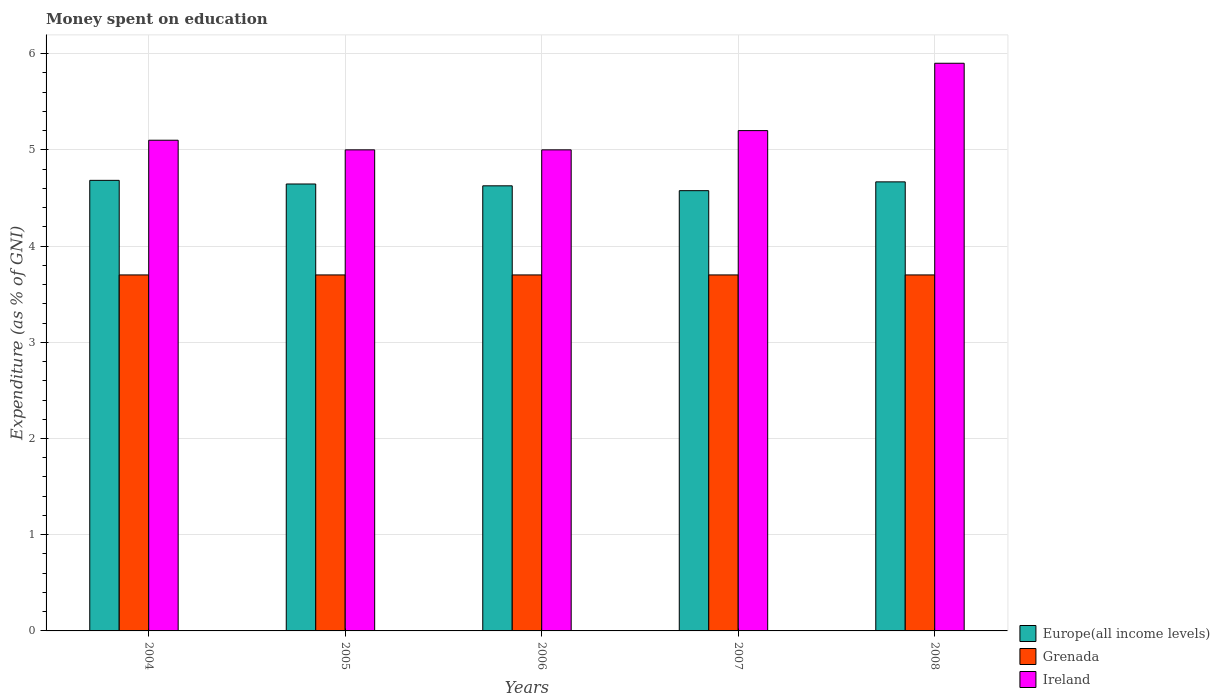How many different coloured bars are there?
Provide a short and direct response. 3. Are the number of bars on each tick of the X-axis equal?
Provide a succinct answer. Yes. What is the label of the 1st group of bars from the left?
Give a very brief answer. 2004. In how many cases, is the number of bars for a given year not equal to the number of legend labels?
Make the answer very short. 0. What is the amount of money spent on education in Ireland in 2007?
Provide a short and direct response. 5.2. Across all years, what is the maximum amount of money spent on education in Grenada?
Ensure brevity in your answer.  3.7. Across all years, what is the minimum amount of money spent on education in Grenada?
Provide a succinct answer. 3.7. In which year was the amount of money spent on education in Ireland maximum?
Offer a very short reply. 2008. What is the total amount of money spent on education in Ireland in the graph?
Give a very brief answer. 26.2. What is the difference between the amount of money spent on education in Grenada in 2005 and that in 2006?
Offer a terse response. 0. What is the difference between the amount of money spent on education in Europe(all income levels) in 2007 and the amount of money spent on education in Grenada in 2005?
Give a very brief answer. 0.88. What is the average amount of money spent on education in Europe(all income levels) per year?
Make the answer very short. 4.64. In the year 2007, what is the difference between the amount of money spent on education in Ireland and amount of money spent on education in Grenada?
Your response must be concise. 1.5. In how many years, is the amount of money spent on education in Europe(all income levels) greater than 5.2 %?
Offer a terse response. 0. What is the ratio of the amount of money spent on education in Europe(all income levels) in 2004 to that in 2005?
Ensure brevity in your answer.  1.01. What is the difference between the highest and the lowest amount of money spent on education in Ireland?
Offer a terse response. 0.9. What does the 1st bar from the left in 2004 represents?
Keep it short and to the point. Europe(all income levels). What does the 3rd bar from the right in 2008 represents?
Provide a short and direct response. Europe(all income levels). Is it the case that in every year, the sum of the amount of money spent on education in Ireland and amount of money spent on education in Europe(all income levels) is greater than the amount of money spent on education in Grenada?
Give a very brief answer. Yes. How many years are there in the graph?
Make the answer very short. 5. What is the difference between two consecutive major ticks on the Y-axis?
Provide a succinct answer. 1. Are the values on the major ticks of Y-axis written in scientific E-notation?
Ensure brevity in your answer.  No. Does the graph contain any zero values?
Your answer should be very brief. No. Where does the legend appear in the graph?
Provide a short and direct response. Bottom right. How many legend labels are there?
Keep it short and to the point. 3. How are the legend labels stacked?
Your response must be concise. Vertical. What is the title of the graph?
Keep it short and to the point. Money spent on education. Does "United Arab Emirates" appear as one of the legend labels in the graph?
Provide a short and direct response. No. What is the label or title of the Y-axis?
Your response must be concise. Expenditure (as % of GNI). What is the Expenditure (as % of GNI) in Europe(all income levels) in 2004?
Provide a succinct answer. 4.68. What is the Expenditure (as % of GNI) in Europe(all income levels) in 2005?
Give a very brief answer. 4.65. What is the Expenditure (as % of GNI) of Grenada in 2005?
Give a very brief answer. 3.7. What is the Expenditure (as % of GNI) of Ireland in 2005?
Make the answer very short. 5. What is the Expenditure (as % of GNI) in Europe(all income levels) in 2006?
Provide a short and direct response. 4.63. What is the Expenditure (as % of GNI) of Ireland in 2006?
Provide a succinct answer. 5. What is the Expenditure (as % of GNI) of Europe(all income levels) in 2007?
Your answer should be compact. 4.58. What is the Expenditure (as % of GNI) in Grenada in 2007?
Your answer should be very brief. 3.7. What is the Expenditure (as % of GNI) of Ireland in 2007?
Provide a succinct answer. 5.2. What is the Expenditure (as % of GNI) in Europe(all income levels) in 2008?
Offer a terse response. 4.67. Across all years, what is the maximum Expenditure (as % of GNI) of Europe(all income levels)?
Provide a short and direct response. 4.68. Across all years, what is the maximum Expenditure (as % of GNI) of Grenada?
Make the answer very short. 3.7. Across all years, what is the minimum Expenditure (as % of GNI) of Europe(all income levels)?
Keep it short and to the point. 4.58. Across all years, what is the minimum Expenditure (as % of GNI) in Ireland?
Your answer should be very brief. 5. What is the total Expenditure (as % of GNI) of Europe(all income levels) in the graph?
Offer a very short reply. 23.2. What is the total Expenditure (as % of GNI) of Ireland in the graph?
Your response must be concise. 26.2. What is the difference between the Expenditure (as % of GNI) of Europe(all income levels) in 2004 and that in 2005?
Give a very brief answer. 0.04. What is the difference between the Expenditure (as % of GNI) in Grenada in 2004 and that in 2005?
Offer a terse response. 0. What is the difference between the Expenditure (as % of GNI) of Europe(all income levels) in 2004 and that in 2006?
Give a very brief answer. 0.06. What is the difference between the Expenditure (as % of GNI) of Europe(all income levels) in 2004 and that in 2007?
Offer a terse response. 0.11. What is the difference between the Expenditure (as % of GNI) of Europe(all income levels) in 2004 and that in 2008?
Make the answer very short. 0.02. What is the difference between the Expenditure (as % of GNI) in Ireland in 2004 and that in 2008?
Ensure brevity in your answer.  -0.8. What is the difference between the Expenditure (as % of GNI) in Europe(all income levels) in 2005 and that in 2006?
Provide a short and direct response. 0.02. What is the difference between the Expenditure (as % of GNI) of Ireland in 2005 and that in 2006?
Provide a short and direct response. 0. What is the difference between the Expenditure (as % of GNI) of Europe(all income levels) in 2005 and that in 2007?
Your answer should be very brief. 0.07. What is the difference between the Expenditure (as % of GNI) in Grenada in 2005 and that in 2007?
Your answer should be compact. 0. What is the difference between the Expenditure (as % of GNI) in Europe(all income levels) in 2005 and that in 2008?
Your answer should be very brief. -0.02. What is the difference between the Expenditure (as % of GNI) in Ireland in 2005 and that in 2008?
Offer a very short reply. -0.9. What is the difference between the Expenditure (as % of GNI) in Europe(all income levels) in 2006 and that in 2007?
Ensure brevity in your answer.  0.05. What is the difference between the Expenditure (as % of GNI) of Europe(all income levels) in 2006 and that in 2008?
Offer a terse response. -0.04. What is the difference between the Expenditure (as % of GNI) of Europe(all income levels) in 2007 and that in 2008?
Ensure brevity in your answer.  -0.09. What is the difference between the Expenditure (as % of GNI) in Ireland in 2007 and that in 2008?
Keep it short and to the point. -0.7. What is the difference between the Expenditure (as % of GNI) in Europe(all income levels) in 2004 and the Expenditure (as % of GNI) in Grenada in 2005?
Your answer should be very brief. 0.98. What is the difference between the Expenditure (as % of GNI) of Europe(all income levels) in 2004 and the Expenditure (as % of GNI) of Ireland in 2005?
Your answer should be compact. -0.32. What is the difference between the Expenditure (as % of GNI) of Grenada in 2004 and the Expenditure (as % of GNI) of Ireland in 2005?
Give a very brief answer. -1.3. What is the difference between the Expenditure (as % of GNI) of Europe(all income levels) in 2004 and the Expenditure (as % of GNI) of Grenada in 2006?
Offer a very short reply. 0.98. What is the difference between the Expenditure (as % of GNI) in Europe(all income levels) in 2004 and the Expenditure (as % of GNI) in Ireland in 2006?
Ensure brevity in your answer.  -0.32. What is the difference between the Expenditure (as % of GNI) of Europe(all income levels) in 2004 and the Expenditure (as % of GNI) of Ireland in 2007?
Ensure brevity in your answer.  -0.52. What is the difference between the Expenditure (as % of GNI) in Grenada in 2004 and the Expenditure (as % of GNI) in Ireland in 2007?
Offer a terse response. -1.5. What is the difference between the Expenditure (as % of GNI) of Europe(all income levels) in 2004 and the Expenditure (as % of GNI) of Grenada in 2008?
Your response must be concise. 0.98. What is the difference between the Expenditure (as % of GNI) in Europe(all income levels) in 2004 and the Expenditure (as % of GNI) in Ireland in 2008?
Offer a terse response. -1.22. What is the difference between the Expenditure (as % of GNI) of Grenada in 2004 and the Expenditure (as % of GNI) of Ireland in 2008?
Provide a succinct answer. -2.2. What is the difference between the Expenditure (as % of GNI) in Europe(all income levels) in 2005 and the Expenditure (as % of GNI) in Grenada in 2006?
Keep it short and to the point. 0.95. What is the difference between the Expenditure (as % of GNI) in Europe(all income levels) in 2005 and the Expenditure (as % of GNI) in Ireland in 2006?
Keep it short and to the point. -0.35. What is the difference between the Expenditure (as % of GNI) in Grenada in 2005 and the Expenditure (as % of GNI) in Ireland in 2006?
Keep it short and to the point. -1.3. What is the difference between the Expenditure (as % of GNI) of Europe(all income levels) in 2005 and the Expenditure (as % of GNI) of Grenada in 2007?
Your answer should be very brief. 0.95. What is the difference between the Expenditure (as % of GNI) of Europe(all income levels) in 2005 and the Expenditure (as % of GNI) of Ireland in 2007?
Offer a terse response. -0.55. What is the difference between the Expenditure (as % of GNI) of Europe(all income levels) in 2005 and the Expenditure (as % of GNI) of Grenada in 2008?
Give a very brief answer. 0.95. What is the difference between the Expenditure (as % of GNI) in Europe(all income levels) in 2005 and the Expenditure (as % of GNI) in Ireland in 2008?
Your answer should be very brief. -1.25. What is the difference between the Expenditure (as % of GNI) in Europe(all income levels) in 2006 and the Expenditure (as % of GNI) in Grenada in 2007?
Provide a short and direct response. 0.93. What is the difference between the Expenditure (as % of GNI) of Europe(all income levels) in 2006 and the Expenditure (as % of GNI) of Ireland in 2007?
Your answer should be very brief. -0.57. What is the difference between the Expenditure (as % of GNI) in Grenada in 2006 and the Expenditure (as % of GNI) in Ireland in 2007?
Keep it short and to the point. -1.5. What is the difference between the Expenditure (as % of GNI) of Europe(all income levels) in 2006 and the Expenditure (as % of GNI) of Grenada in 2008?
Provide a succinct answer. 0.93. What is the difference between the Expenditure (as % of GNI) of Europe(all income levels) in 2006 and the Expenditure (as % of GNI) of Ireland in 2008?
Your answer should be compact. -1.27. What is the difference between the Expenditure (as % of GNI) of Grenada in 2006 and the Expenditure (as % of GNI) of Ireland in 2008?
Provide a succinct answer. -2.2. What is the difference between the Expenditure (as % of GNI) of Europe(all income levels) in 2007 and the Expenditure (as % of GNI) of Grenada in 2008?
Give a very brief answer. 0.88. What is the difference between the Expenditure (as % of GNI) in Europe(all income levels) in 2007 and the Expenditure (as % of GNI) in Ireland in 2008?
Provide a succinct answer. -1.32. What is the difference between the Expenditure (as % of GNI) of Grenada in 2007 and the Expenditure (as % of GNI) of Ireland in 2008?
Give a very brief answer. -2.2. What is the average Expenditure (as % of GNI) of Europe(all income levels) per year?
Provide a short and direct response. 4.64. What is the average Expenditure (as % of GNI) of Grenada per year?
Ensure brevity in your answer.  3.7. What is the average Expenditure (as % of GNI) in Ireland per year?
Your answer should be compact. 5.24. In the year 2004, what is the difference between the Expenditure (as % of GNI) of Europe(all income levels) and Expenditure (as % of GNI) of Ireland?
Provide a succinct answer. -0.42. In the year 2004, what is the difference between the Expenditure (as % of GNI) in Grenada and Expenditure (as % of GNI) in Ireland?
Provide a succinct answer. -1.4. In the year 2005, what is the difference between the Expenditure (as % of GNI) in Europe(all income levels) and Expenditure (as % of GNI) in Grenada?
Your answer should be compact. 0.95. In the year 2005, what is the difference between the Expenditure (as % of GNI) of Europe(all income levels) and Expenditure (as % of GNI) of Ireland?
Offer a very short reply. -0.35. In the year 2005, what is the difference between the Expenditure (as % of GNI) of Grenada and Expenditure (as % of GNI) of Ireland?
Keep it short and to the point. -1.3. In the year 2006, what is the difference between the Expenditure (as % of GNI) in Europe(all income levels) and Expenditure (as % of GNI) in Grenada?
Offer a very short reply. 0.93. In the year 2006, what is the difference between the Expenditure (as % of GNI) in Europe(all income levels) and Expenditure (as % of GNI) in Ireland?
Offer a terse response. -0.37. In the year 2007, what is the difference between the Expenditure (as % of GNI) of Europe(all income levels) and Expenditure (as % of GNI) of Grenada?
Your response must be concise. 0.88. In the year 2007, what is the difference between the Expenditure (as % of GNI) of Europe(all income levels) and Expenditure (as % of GNI) of Ireland?
Offer a terse response. -0.62. In the year 2007, what is the difference between the Expenditure (as % of GNI) in Grenada and Expenditure (as % of GNI) in Ireland?
Give a very brief answer. -1.5. In the year 2008, what is the difference between the Expenditure (as % of GNI) in Europe(all income levels) and Expenditure (as % of GNI) in Grenada?
Your answer should be very brief. 0.97. In the year 2008, what is the difference between the Expenditure (as % of GNI) of Europe(all income levels) and Expenditure (as % of GNI) of Ireland?
Offer a terse response. -1.23. In the year 2008, what is the difference between the Expenditure (as % of GNI) in Grenada and Expenditure (as % of GNI) in Ireland?
Provide a succinct answer. -2.2. What is the ratio of the Expenditure (as % of GNI) in Europe(all income levels) in 2004 to that in 2005?
Offer a terse response. 1.01. What is the ratio of the Expenditure (as % of GNI) of Grenada in 2004 to that in 2005?
Provide a short and direct response. 1. What is the ratio of the Expenditure (as % of GNI) in Ireland in 2004 to that in 2005?
Your response must be concise. 1.02. What is the ratio of the Expenditure (as % of GNI) of Europe(all income levels) in 2004 to that in 2006?
Give a very brief answer. 1.01. What is the ratio of the Expenditure (as % of GNI) in Europe(all income levels) in 2004 to that in 2007?
Provide a succinct answer. 1.02. What is the ratio of the Expenditure (as % of GNI) of Ireland in 2004 to that in 2007?
Provide a succinct answer. 0.98. What is the ratio of the Expenditure (as % of GNI) in Europe(all income levels) in 2004 to that in 2008?
Make the answer very short. 1. What is the ratio of the Expenditure (as % of GNI) in Ireland in 2004 to that in 2008?
Provide a succinct answer. 0.86. What is the ratio of the Expenditure (as % of GNI) of Europe(all income levels) in 2005 to that in 2006?
Ensure brevity in your answer.  1. What is the ratio of the Expenditure (as % of GNI) in Grenada in 2005 to that in 2006?
Offer a very short reply. 1. What is the ratio of the Expenditure (as % of GNI) in Ireland in 2005 to that in 2006?
Offer a very short reply. 1. What is the ratio of the Expenditure (as % of GNI) of Europe(all income levels) in 2005 to that in 2007?
Your answer should be very brief. 1.02. What is the ratio of the Expenditure (as % of GNI) of Ireland in 2005 to that in 2007?
Your response must be concise. 0.96. What is the ratio of the Expenditure (as % of GNI) of Europe(all income levels) in 2005 to that in 2008?
Offer a very short reply. 1. What is the ratio of the Expenditure (as % of GNI) in Grenada in 2005 to that in 2008?
Make the answer very short. 1. What is the ratio of the Expenditure (as % of GNI) of Ireland in 2005 to that in 2008?
Keep it short and to the point. 0.85. What is the ratio of the Expenditure (as % of GNI) of Europe(all income levels) in 2006 to that in 2007?
Your answer should be compact. 1.01. What is the ratio of the Expenditure (as % of GNI) of Ireland in 2006 to that in 2007?
Your answer should be compact. 0.96. What is the ratio of the Expenditure (as % of GNI) of Europe(all income levels) in 2006 to that in 2008?
Offer a very short reply. 0.99. What is the ratio of the Expenditure (as % of GNI) in Ireland in 2006 to that in 2008?
Make the answer very short. 0.85. What is the ratio of the Expenditure (as % of GNI) in Europe(all income levels) in 2007 to that in 2008?
Your answer should be compact. 0.98. What is the ratio of the Expenditure (as % of GNI) in Grenada in 2007 to that in 2008?
Make the answer very short. 1. What is the ratio of the Expenditure (as % of GNI) in Ireland in 2007 to that in 2008?
Your answer should be compact. 0.88. What is the difference between the highest and the second highest Expenditure (as % of GNI) of Europe(all income levels)?
Ensure brevity in your answer.  0.02. What is the difference between the highest and the lowest Expenditure (as % of GNI) in Europe(all income levels)?
Offer a very short reply. 0.11. What is the difference between the highest and the lowest Expenditure (as % of GNI) in Grenada?
Your response must be concise. 0. What is the difference between the highest and the lowest Expenditure (as % of GNI) in Ireland?
Your response must be concise. 0.9. 